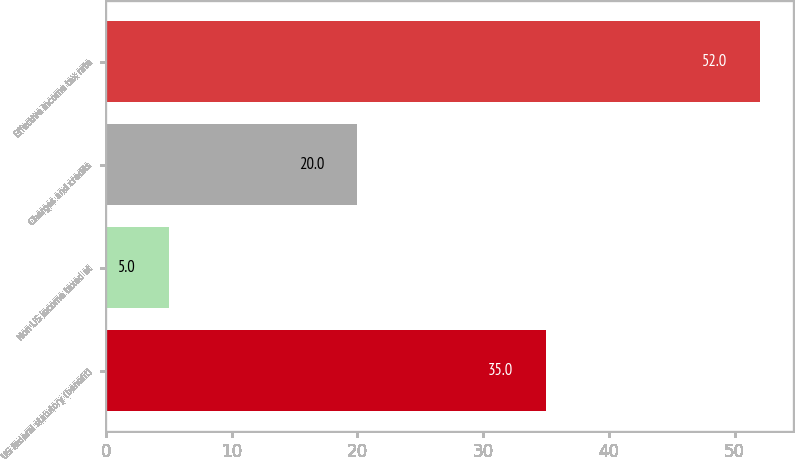Convert chart. <chart><loc_0><loc_0><loc_500><loc_500><bar_chart><fcel>US federal statutory (benefit)<fcel>Non US income taxed at<fcel>Charges and credits<fcel>Effective income tax rate<nl><fcel>35<fcel>5<fcel>20<fcel>52<nl></chart> 